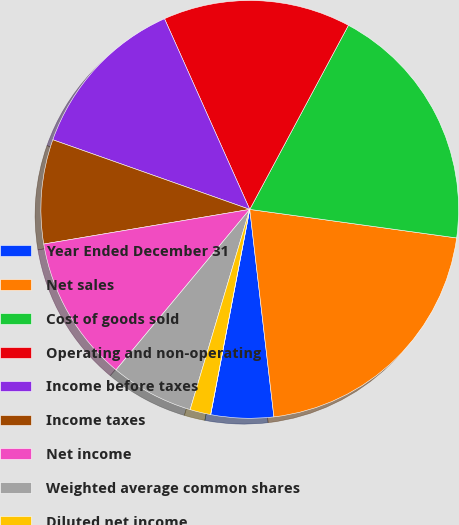Convert chart. <chart><loc_0><loc_0><loc_500><loc_500><pie_chart><fcel>Year Ended December 31<fcel>Net sales<fcel>Cost of goods sold<fcel>Operating and non-operating<fcel>Income before taxes<fcel>Income taxes<fcel>Net income<fcel>Weighted average common shares<fcel>Diluted net income<fcel>Dividends declared<nl><fcel>4.84%<fcel>20.97%<fcel>19.35%<fcel>14.52%<fcel>12.9%<fcel>8.06%<fcel>11.29%<fcel>6.45%<fcel>1.61%<fcel>0.0%<nl></chart> 